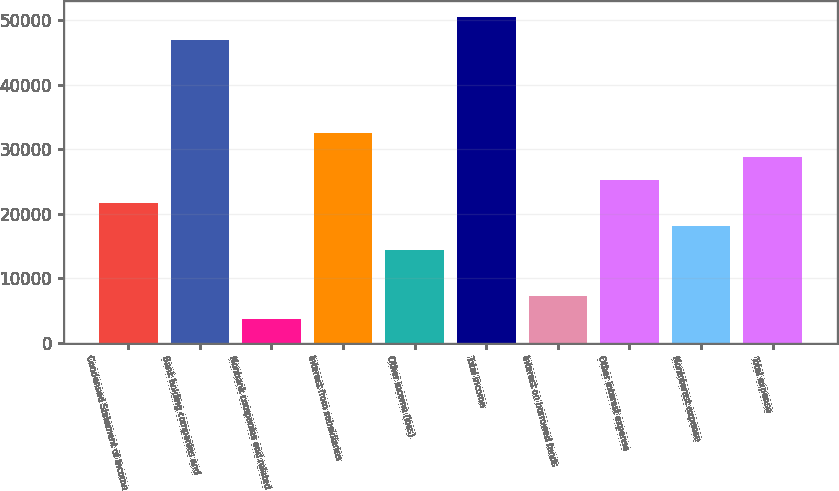Convert chart to OTSL. <chart><loc_0><loc_0><loc_500><loc_500><bar_chart><fcel>Condensed Statement of Income<fcel>Bank holding companies and<fcel>Nonbank companies and related<fcel>Interest from subsidiaries<fcel>Other income (loss)<fcel>Total income<fcel>Interest on borrowed funds<fcel>Other interest expense<fcel>Noninterest expense<fcel>Total expense<nl><fcel>21663.6<fcel>46867.8<fcel>3660.6<fcel>32465.4<fcel>14462.4<fcel>50468.4<fcel>7261.2<fcel>25264.2<fcel>18063<fcel>28864.8<nl></chart> 